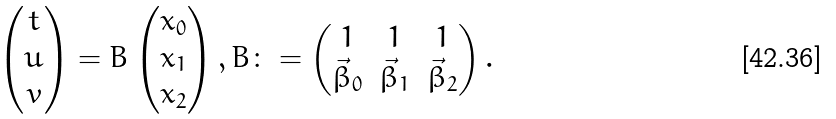Convert formula to latex. <formula><loc_0><loc_0><loc_500><loc_500>\begin{pmatrix} t \\ u \\ v \end{pmatrix} = B \begin{pmatrix} x _ { 0 } \\ x _ { 1 } \\ x _ { 2 } \end{pmatrix} , B \colon = \begin{pmatrix} 1 & 1 & 1 \\ \vec { \beta } _ { 0 } & \vec { \beta } _ { 1 } & \vec { \beta } _ { 2 } \end{pmatrix} .</formula> 